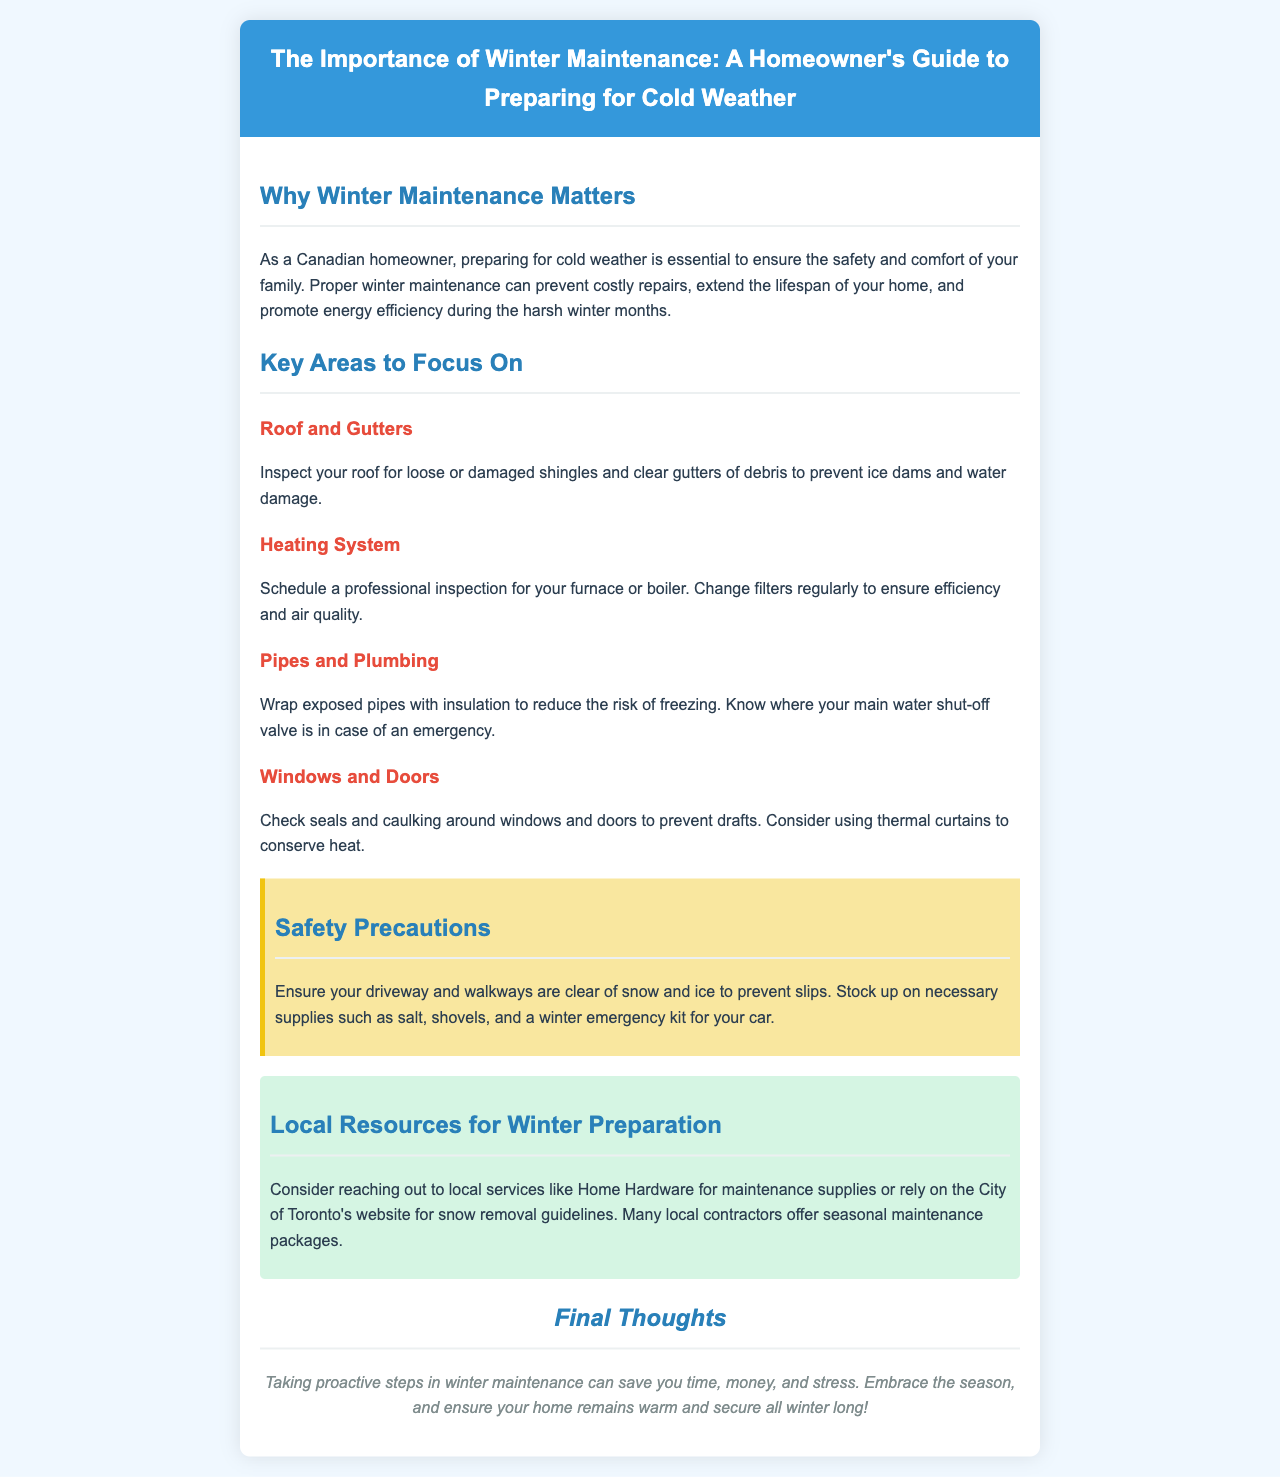What is the title of the brochure? The title of the brochure is presented in the header section of the document.
Answer: The Importance of Winter Maintenance: A Homeowner's Guide to Preparing for Cold Weather How many key areas are to focus on for winter maintenance? The document outlines several key areas to focus on, listed under the respective section.
Answer: Four What should you inspect on your roof? The document specifies that you need to inspect your roof for certain conditions to prevent issues.
Answer: Loose or damaged shingles Where can you find snow removal guidelines? The document mentions a local resource that provides information on snow removal.
Answer: City of Toronto's website What should you stock up on for safety precautions? The safety section details necessary supplies to be prepared for winter.
Answer: Salt, shovels, and a winter emergency kit Which system should have a professional inspection? The brochure advises a specific system that is crucial for winter heating and comfort.
Answer: Heating system What should be checked around windows and doors? The document emphasizes maintaining certain features surrounding these home components.
Answer: Seals and caulking What is one benefit of winter maintenance mentioned? The brochure outlines several advantages of taking proactive steps regarding winter preparations.
Answer: Prevent costly repairs 